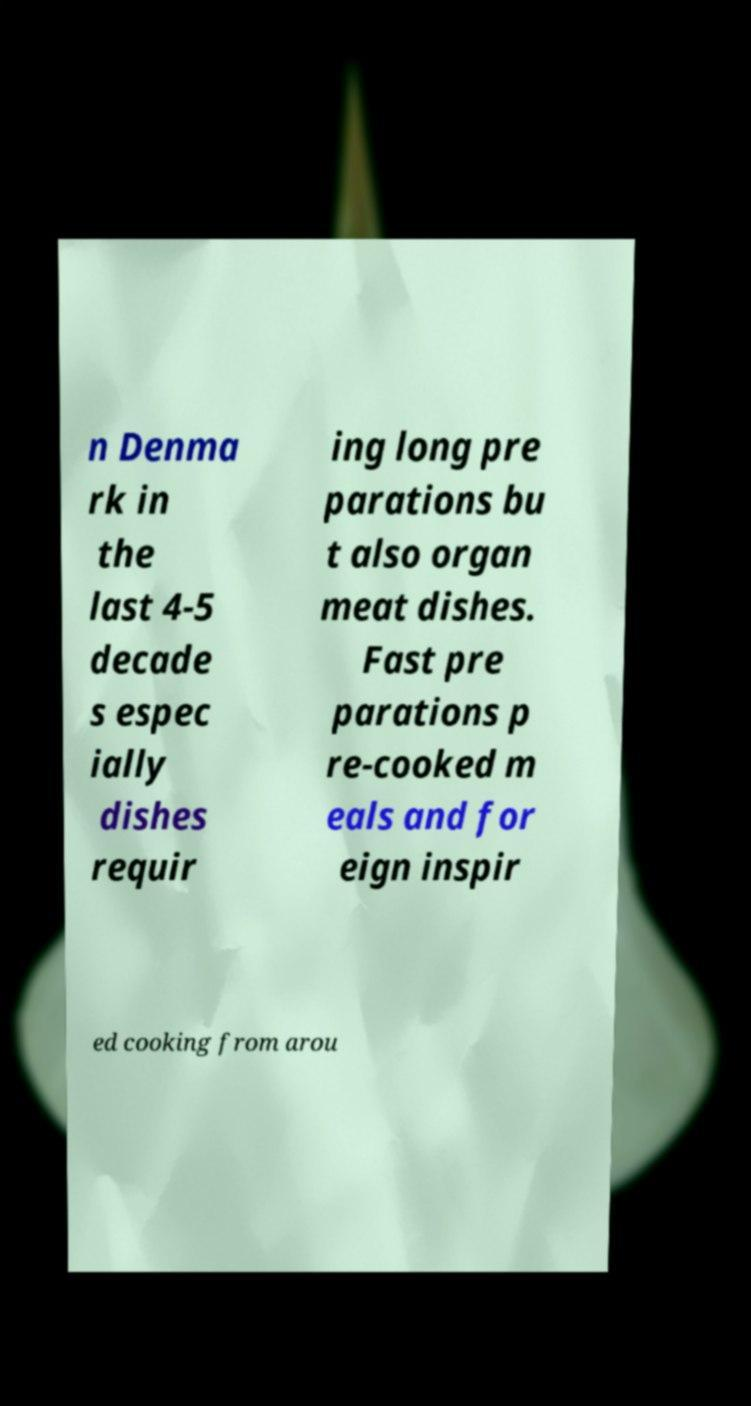Can you accurately transcribe the text from the provided image for me? n Denma rk in the last 4-5 decade s espec ially dishes requir ing long pre parations bu t also organ meat dishes. Fast pre parations p re-cooked m eals and for eign inspir ed cooking from arou 